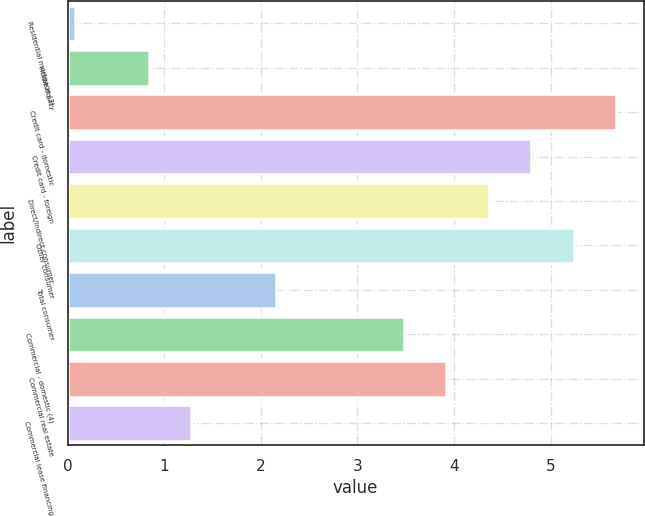<chart> <loc_0><loc_0><loc_500><loc_500><bar_chart><fcel>Residential mortgage (3)<fcel>Home equity<fcel>Credit card - domestic<fcel>Credit card - foreign<fcel>Direct/Indirect consumer<fcel>Other consumer<fcel>Total consumer<fcel>Commercial - domestic (4)<fcel>Commercial real estate<fcel>Commercial lease financing<nl><fcel>0.08<fcel>0.84<fcel>5.68<fcel>4.8<fcel>4.36<fcel>5.24<fcel>2.16<fcel>3.48<fcel>3.92<fcel>1.28<nl></chart> 